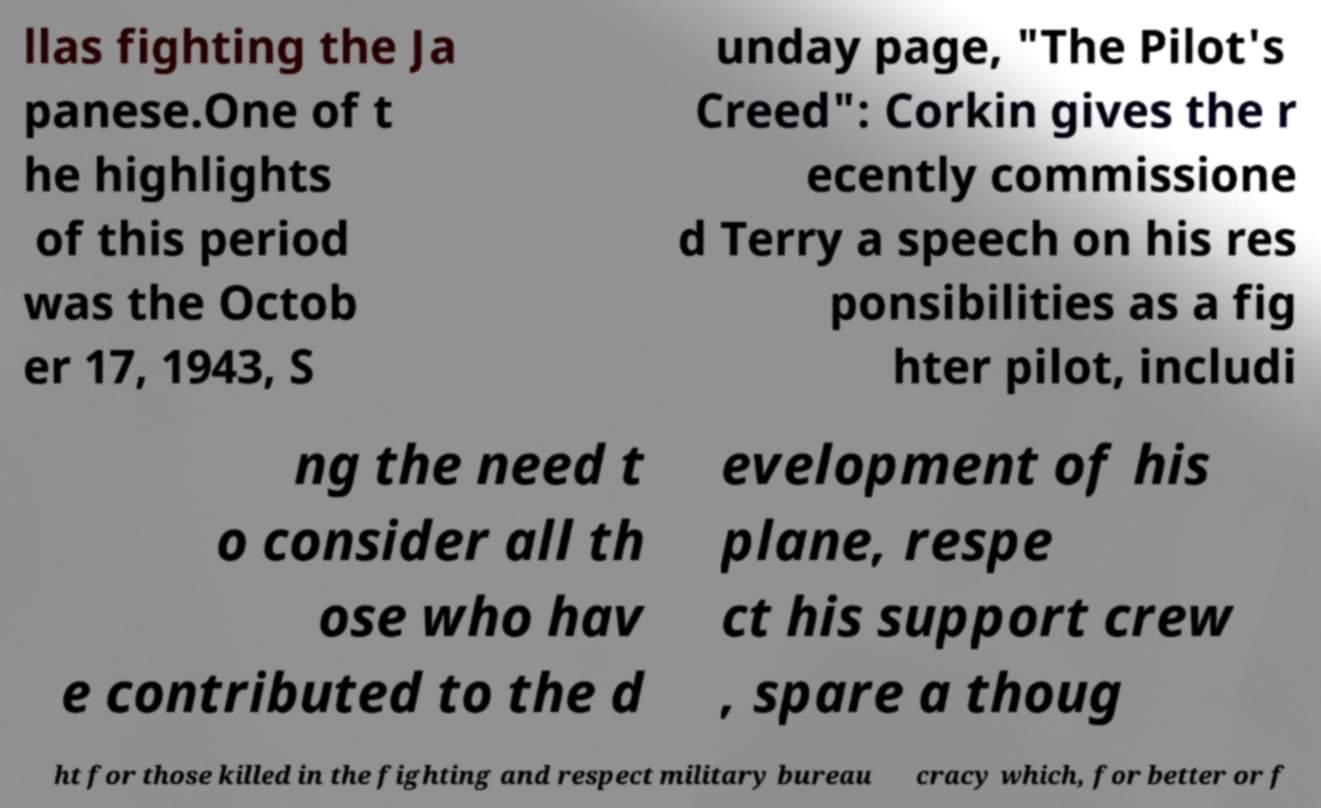Please read and relay the text visible in this image. What does it say? llas fighting the Ja panese.One of t he highlights of this period was the Octob er 17, 1943, S unday page, "The Pilot's Creed": Corkin gives the r ecently commissione d Terry a speech on his res ponsibilities as a fig hter pilot, includi ng the need t o consider all th ose who hav e contributed to the d evelopment of his plane, respe ct his support crew , spare a thoug ht for those killed in the fighting and respect military bureau cracy which, for better or f 